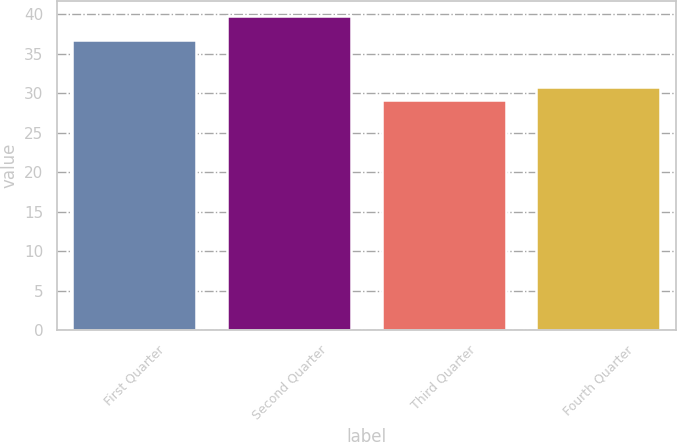<chart> <loc_0><loc_0><loc_500><loc_500><bar_chart><fcel>First Quarter<fcel>Second Quarter<fcel>Third Quarter<fcel>Fourth Quarter<nl><fcel>36.67<fcel>39.71<fcel>29.12<fcel>30.8<nl></chart> 